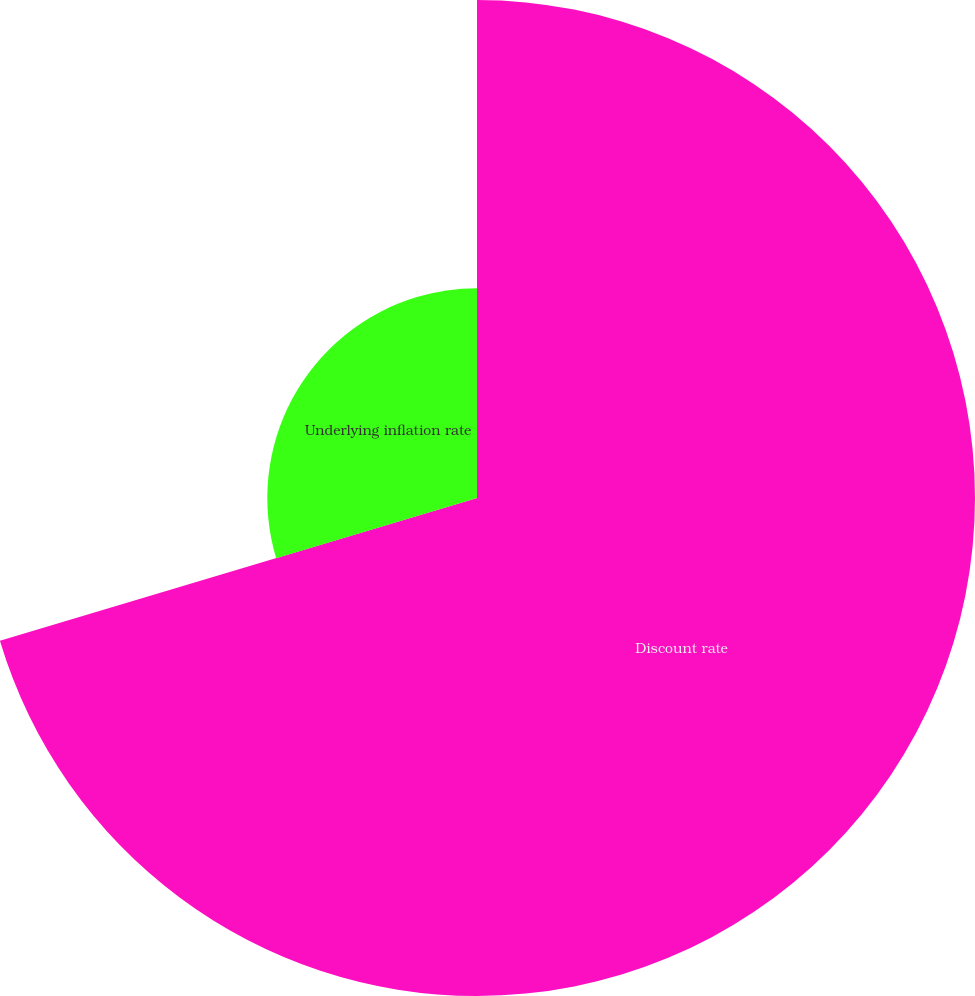Convert chart. <chart><loc_0><loc_0><loc_500><loc_500><pie_chart><fcel>Discount rate<fcel>Underlying inflation rate<nl><fcel>70.37%<fcel>29.63%<nl></chart> 